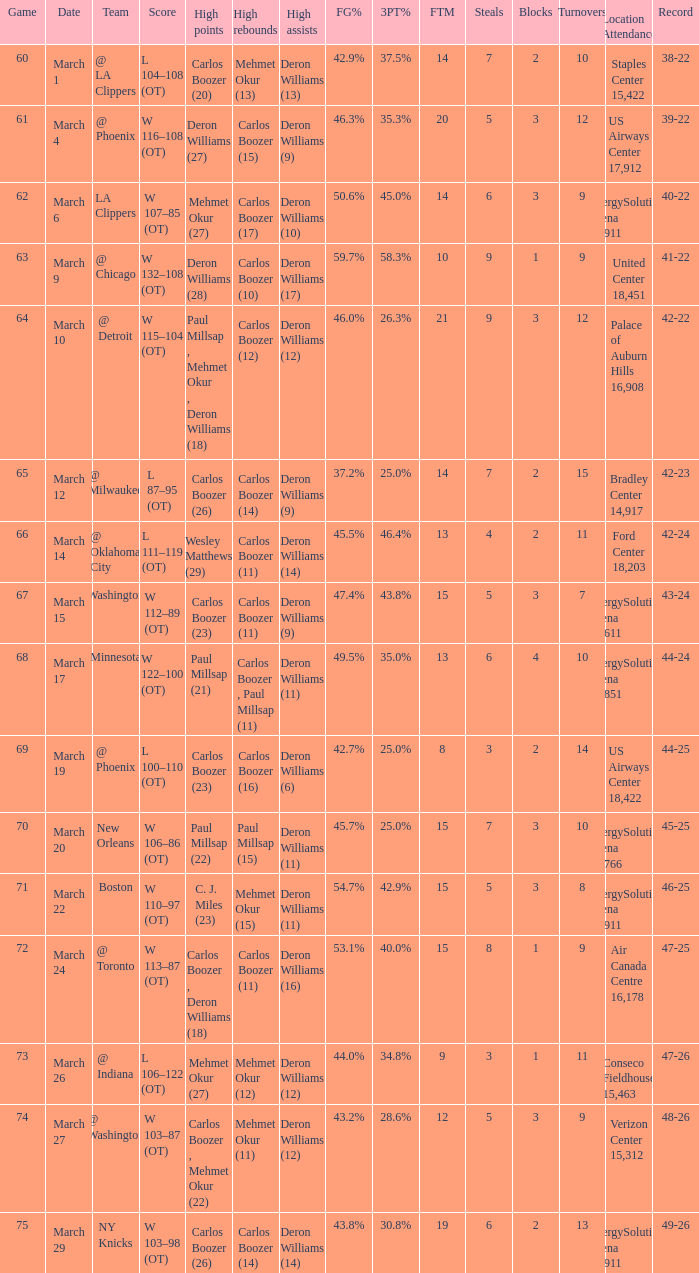How many players did the most high points in the game with 39-22 record? 1.0. 